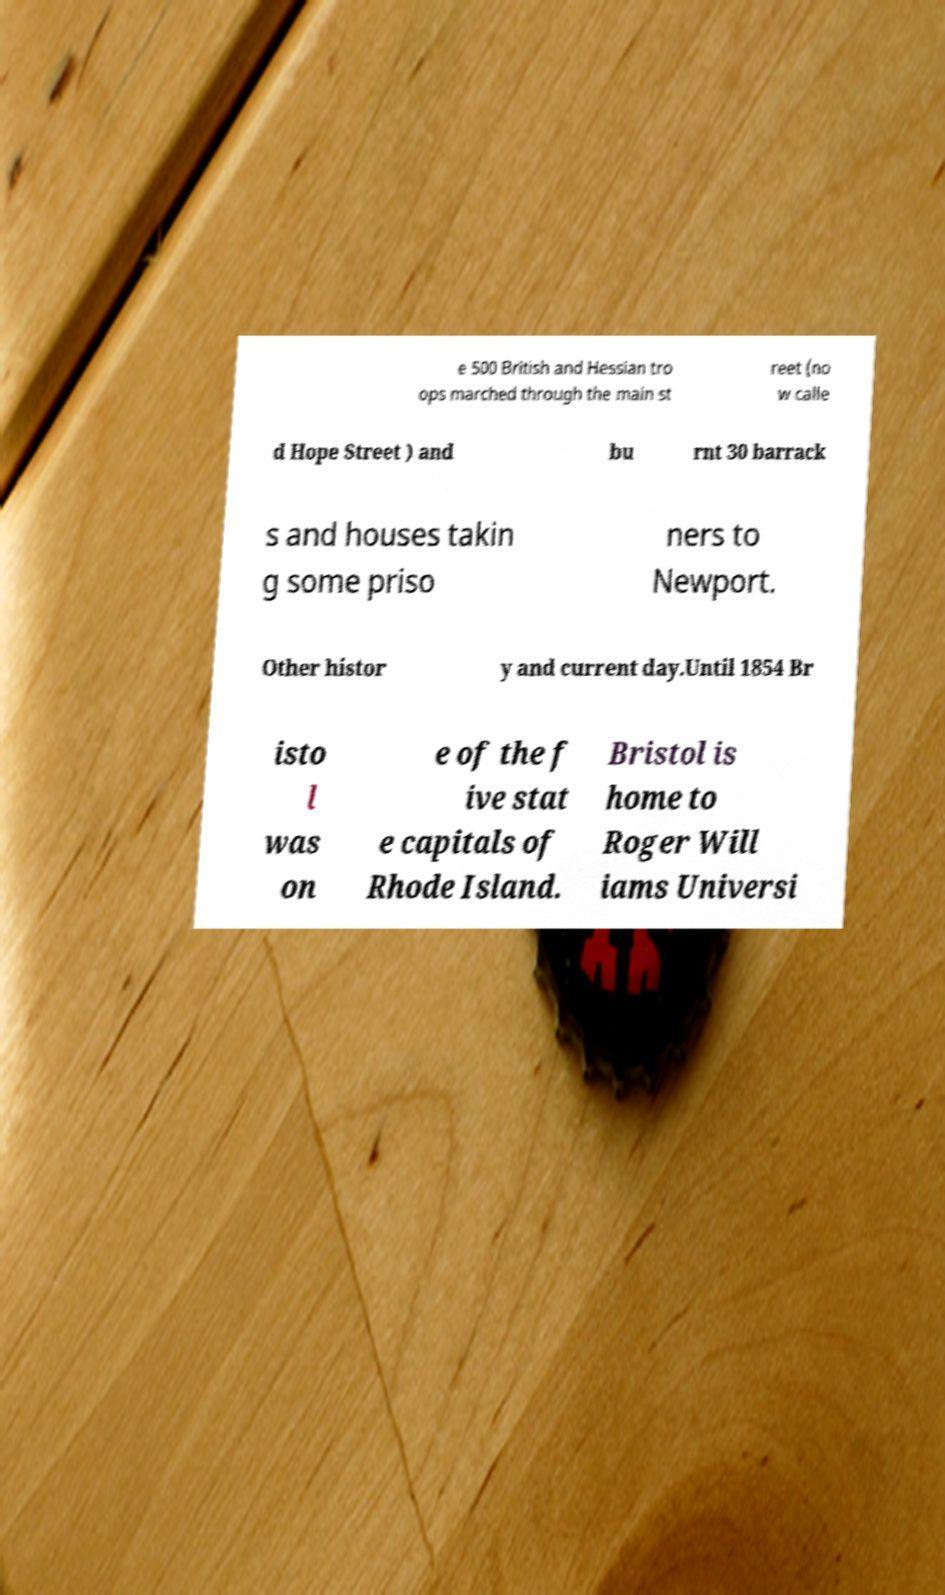There's text embedded in this image that I need extracted. Can you transcribe it verbatim? e 500 British and Hessian tro ops marched through the main st reet (no w calle d Hope Street ) and bu rnt 30 barrack s and houses takin g some priso ners to Newport. Other histor y and current day.Until 1854 Br isto l was on e of the f ive stat e capitals of Rhode Island. Bristol is home to Roger Will iams Universi 